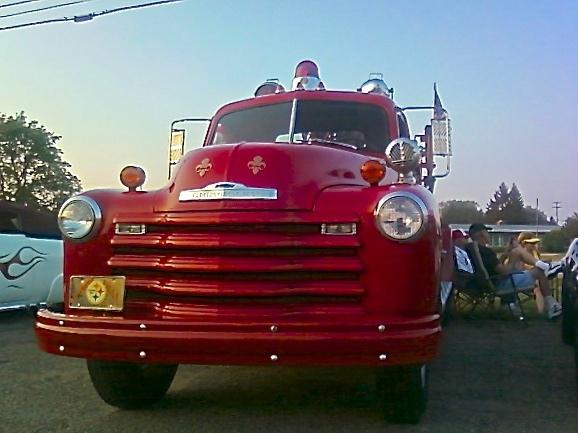What do those riding this vessel use to do their jobs?

Choices:
A) air
B) milk
C) water
D) singing water 